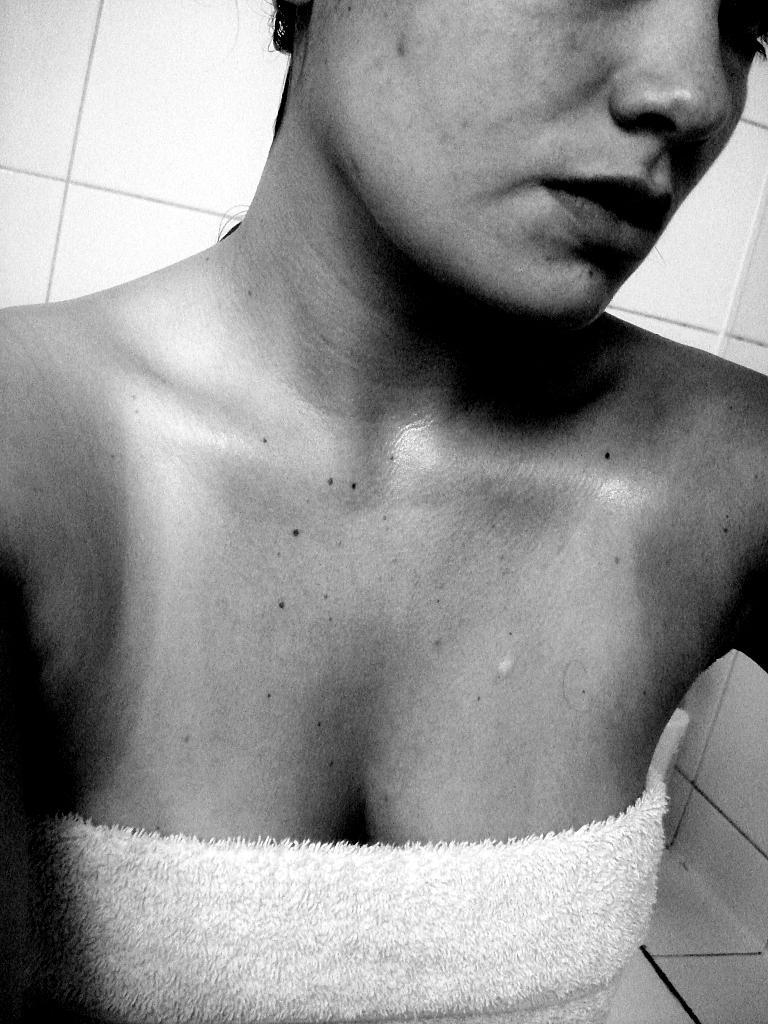Please provide a concise description of this image. In this image I can see the person with the dress. In the back there's a wall. And this is a black and white image. 